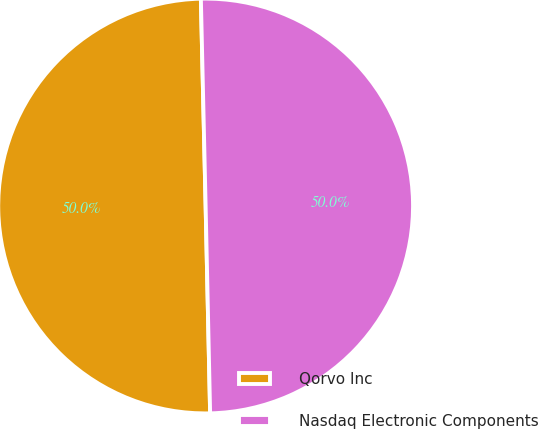<chart> <loc_0><loc_0><loc_500><loc_500><pie_chart><fcel>Qorvo Inc<fcel>Nasdaq Electronic Components<nl><fcel>49.98%<fcel>50.02%<nl></chart> 